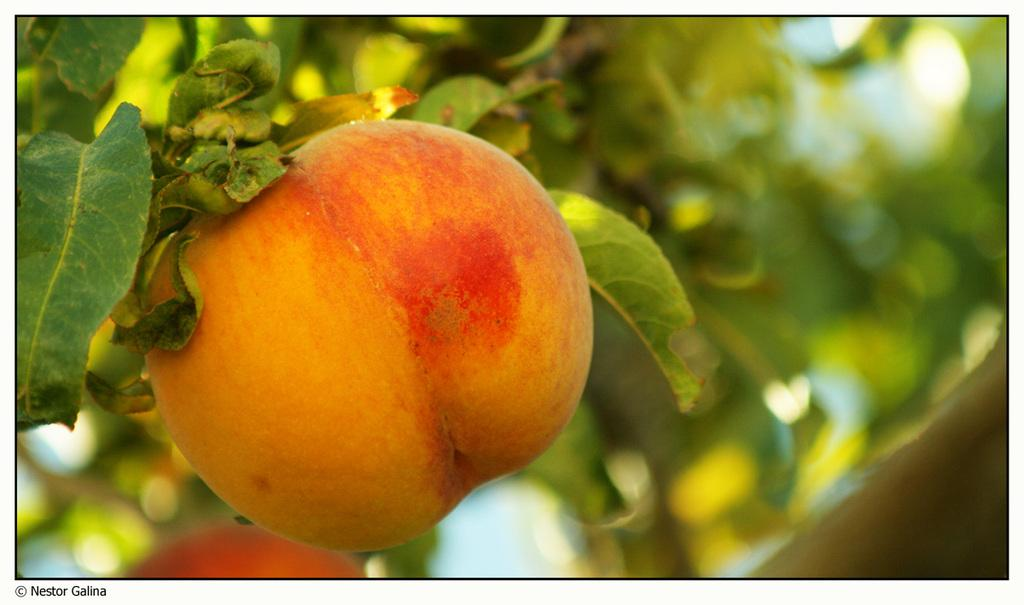What type of food can be seen in the image? There are fruits in the image. What can be seen in the background of the image? There are leaves in the background of the image. How would you describe the clarity of the image? The image is blurry. How many ants are crawling on the bread in the image? There is no bread or ants present in the image; it features fruits and leaves. 